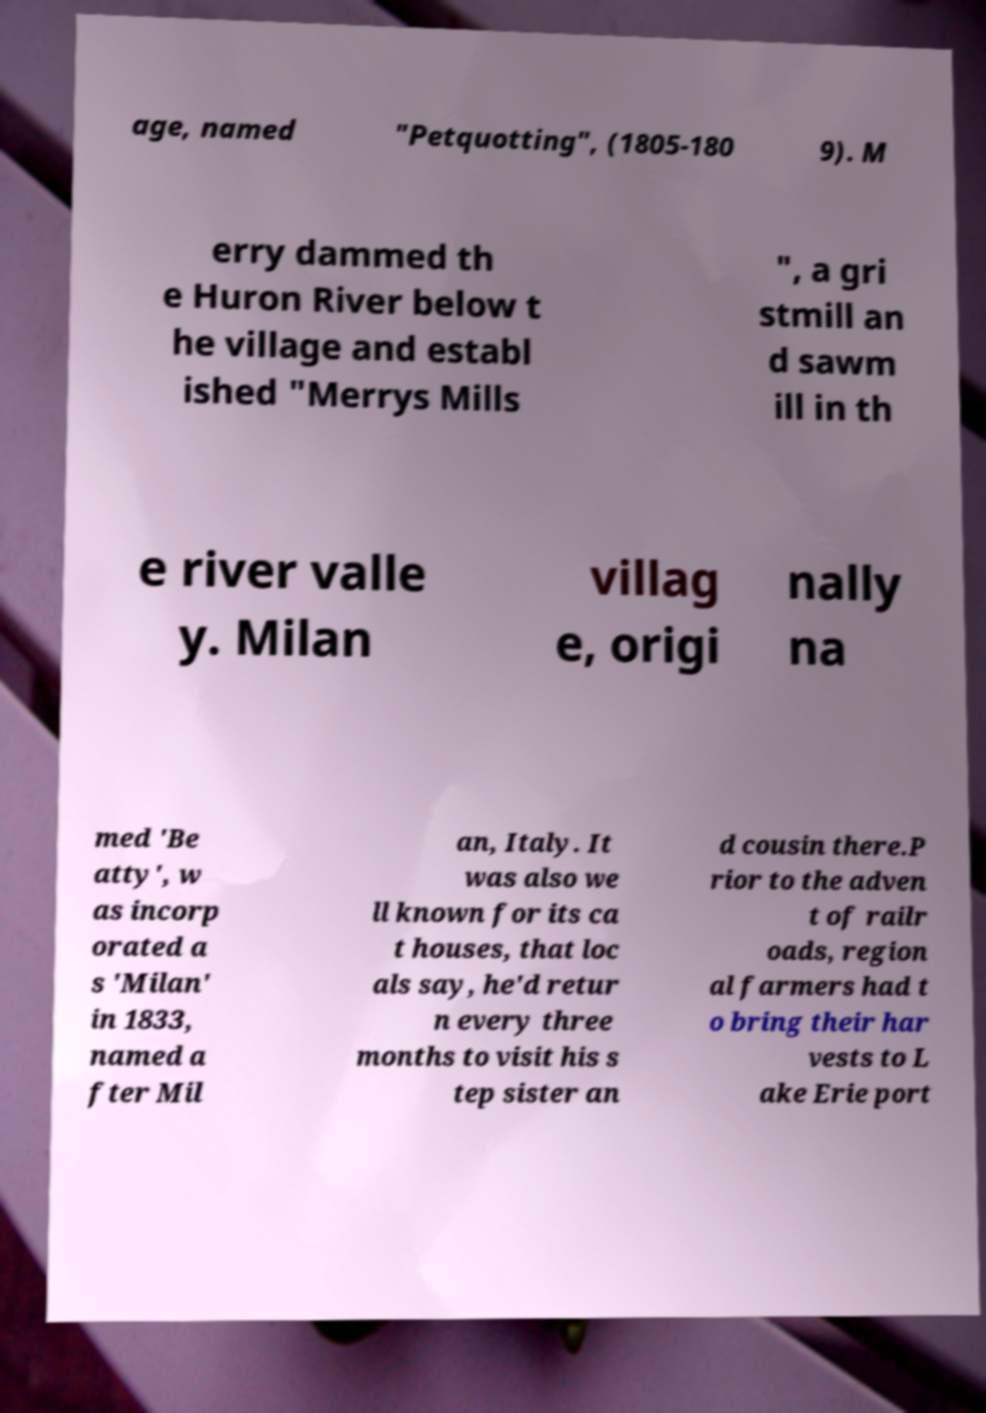For documentation purposes, I need the text within this image transcribed. Could you provide that? age, named "Petquotting", (1805-180 9). M erry dammed th e Huron River below t he village and establ ished "Merrys Mills ", a gri stmill an d sawm ill in th e river valle y. Milan villag e, origi nally na med 'Be atty', w as incorp orated a s 'Milan' in 1833, named a fter Mil an, Italy. It was also we ll known for its ca t houses, that loc als say, he'd retur n every three months to visit his s tep sister an d cousin there.P rior to the adven t of railr oads, region al farmers had t o bring their har vests to L ake Erie port 